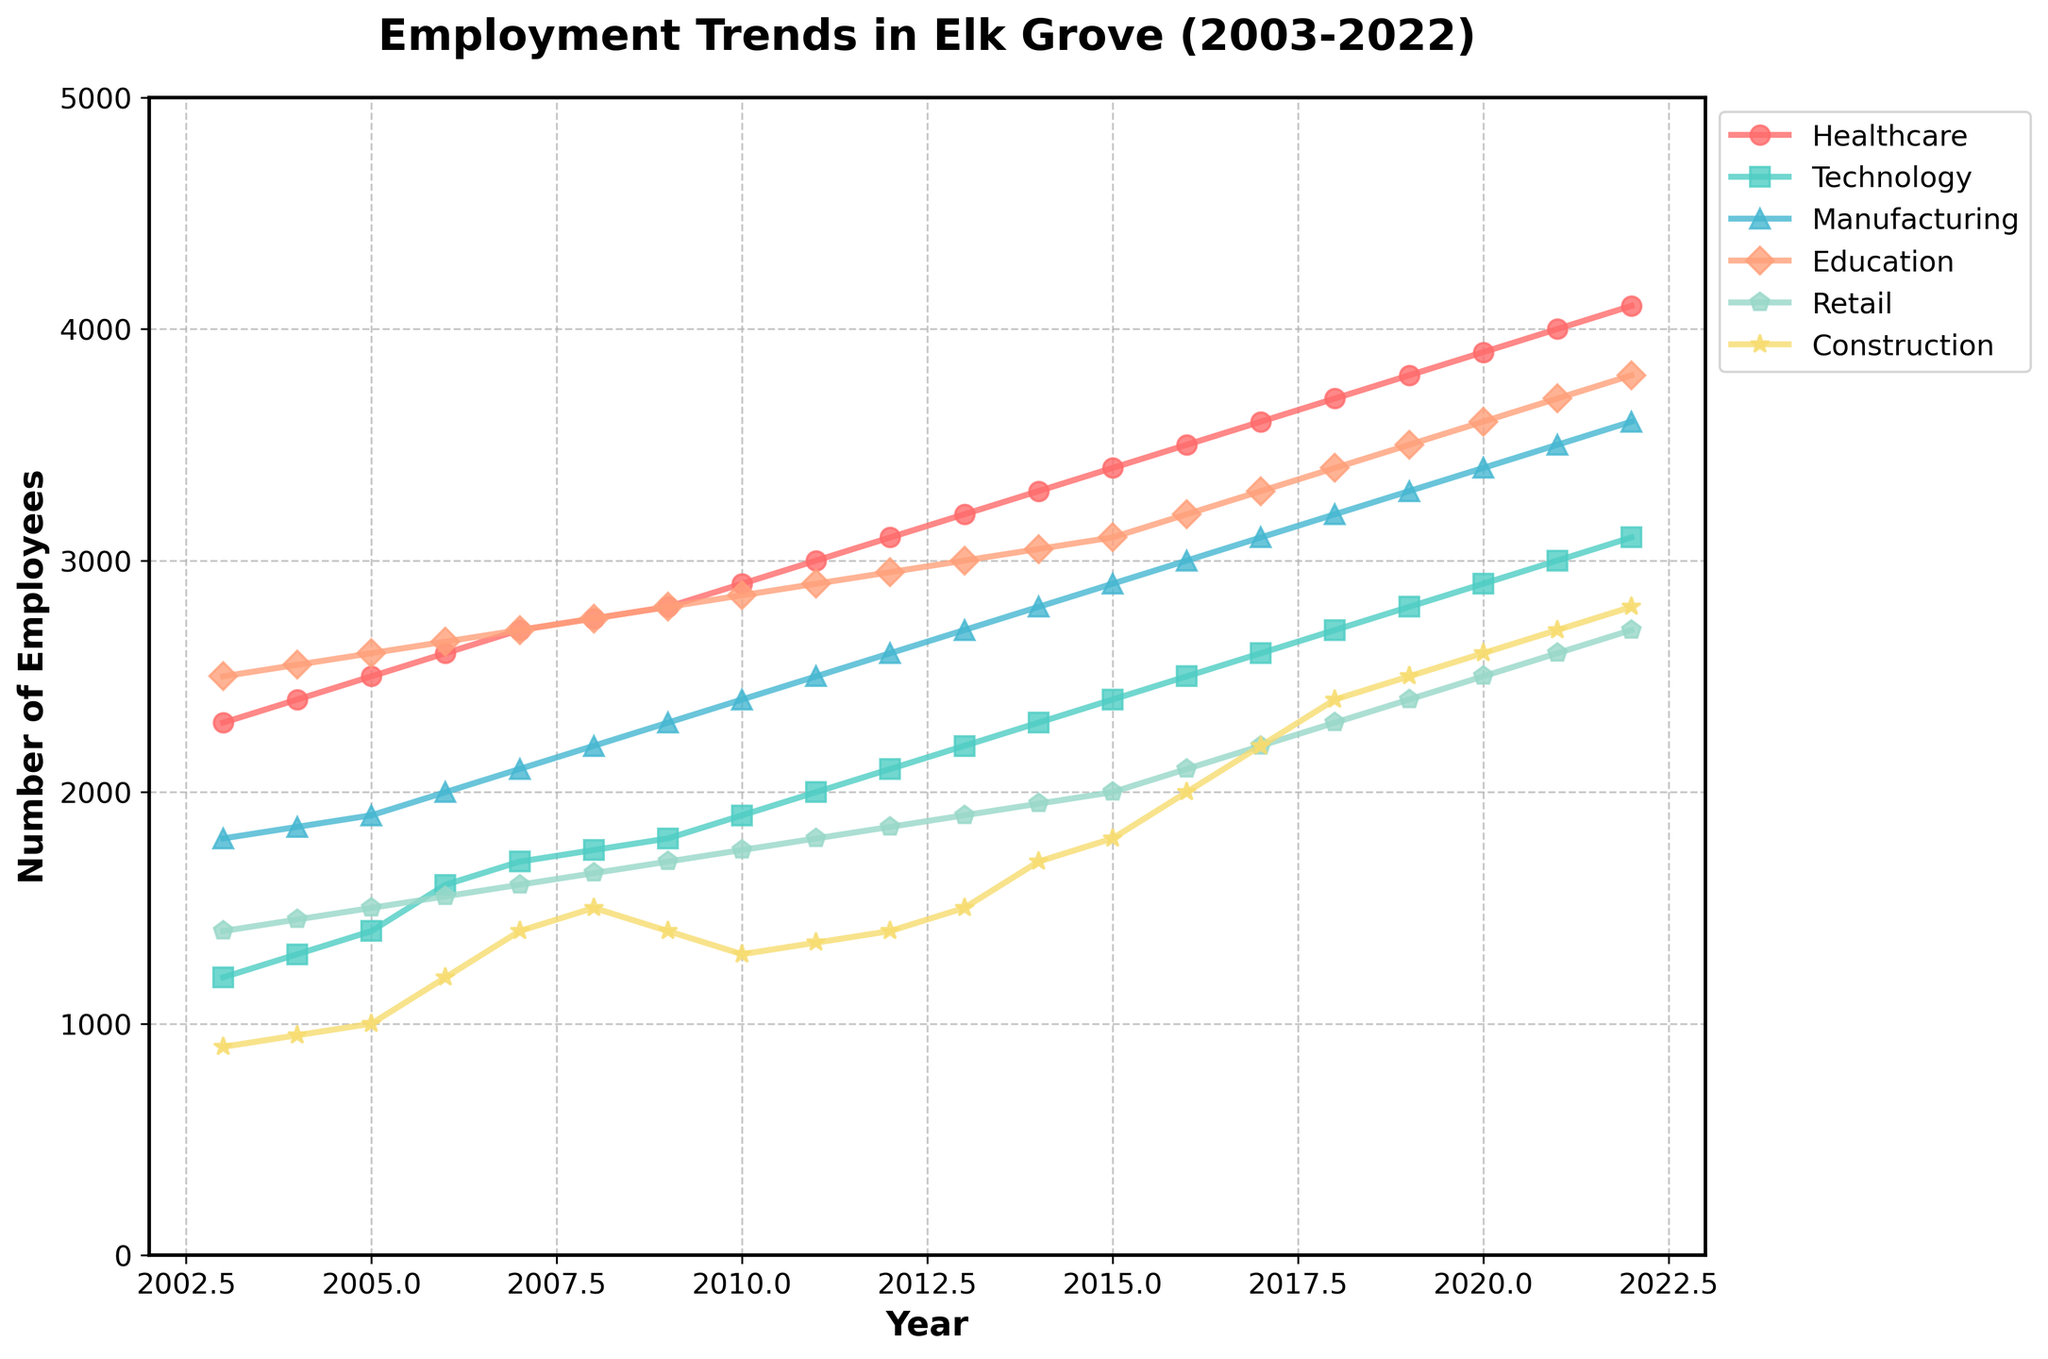What is the title of the figure? The title is located at the top of the figure and is meant to provide a summary of what the chart represents.
Answer: Employment Trends in Elk Grove (2003-2022) How many industries are represented in the figure? The figure uses six different colors and markers to represent the industries. By counting these, we can determine the number of industries.
Answer: 6 Which industry had the highest number of employees in 2022? By looking at the end of the lines for each industry in the year 2022, we can compare their values to see which one is the highest.
Answer: Healthcare What is the range of the y-axis? The y-axis represents the number of employees and the range can be seen from the lowest to the highest value marked along the y-axis.
Answer: 0 to 5000 How many years are covered in the figure? By counting the tick marks along the x-axis from 2003 to 2022, we can determine the number of years covered.
Answer: 20 Which industry had a greater increase in employees from 2003 to 2022, Technology or Retail? We need to subtract the 2003 value from the 2022 value for both Technology and Retail, and then compare the differences. Technology: 3100 - 1200 = 1900; Retail: 2700 - 1400 = 1300. Technology increased more.
Answer: Technology What was the number of employees in Construction in the year 2008? The data point for Construction in 2008 can be observed directly from the figure or its corresponding marker.
Answer: 1500 Which industry saw a steady increase without any drop from 2003 to 2022? By examining the trend lines for all industries, we look for one that consistently goes upwards without any downward trend at any point.
Answer: Education Which two industries had the closest number of employees in 2010? By comparing the values for each industry in the year 2010 and looking for the smallest difference, we can determine this. Technology: 1900, Retail: 1750. Difference is 150.
Answer: Technology and Retail What's the difference in the number of employees between Healthcare and Manufacturing in 2020? Subtract the number of employees in Manufacturing from the number in Healthcare for the year 2020. Healthcare: 3900; Manufacturing: 3400. Difference is 3900 - 3400.
Answer: 500 